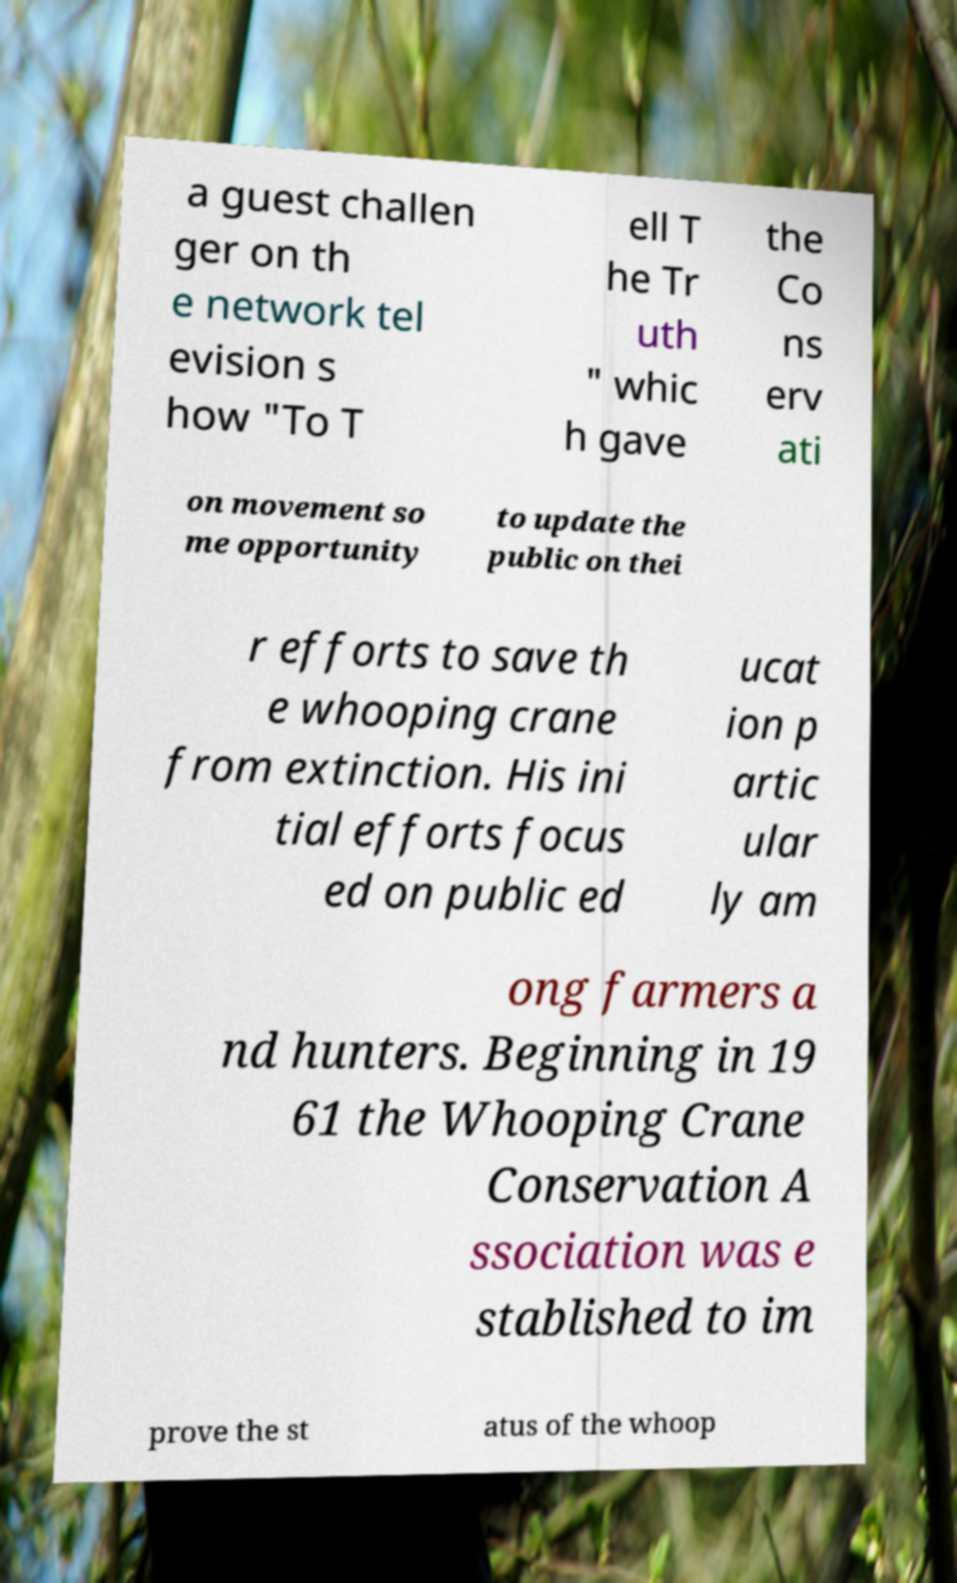What messages or text are displayed in this image? I need them in a readable, typed format. a guest challen ger on th e network tel evision s how "To T ell T he Tr uth " whic h gave the Co ns erv ati on movement so me opportunity to update the public on thei r efforts to save th e whooping crane from extinction. His ini tial efforts focus ed on public ed ucat ion p artic ular ly am ong farmers a nd hunters. Beginning in 19 61 the Whooping Crane Conservation A ssociation was e stablished to im prove the st atus of the whoop 